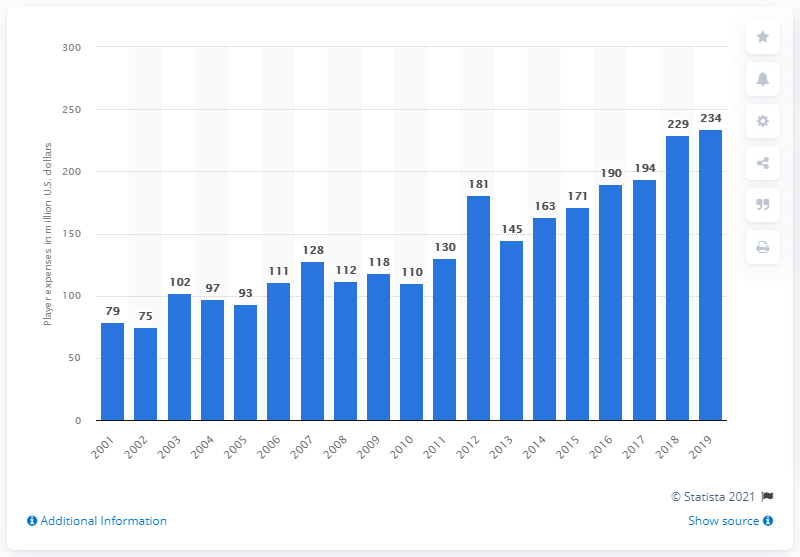Specify some key components in this picture. The player expenses for the Tampa Bay Buccaneers in the 2019 season were approximately $234 million. 